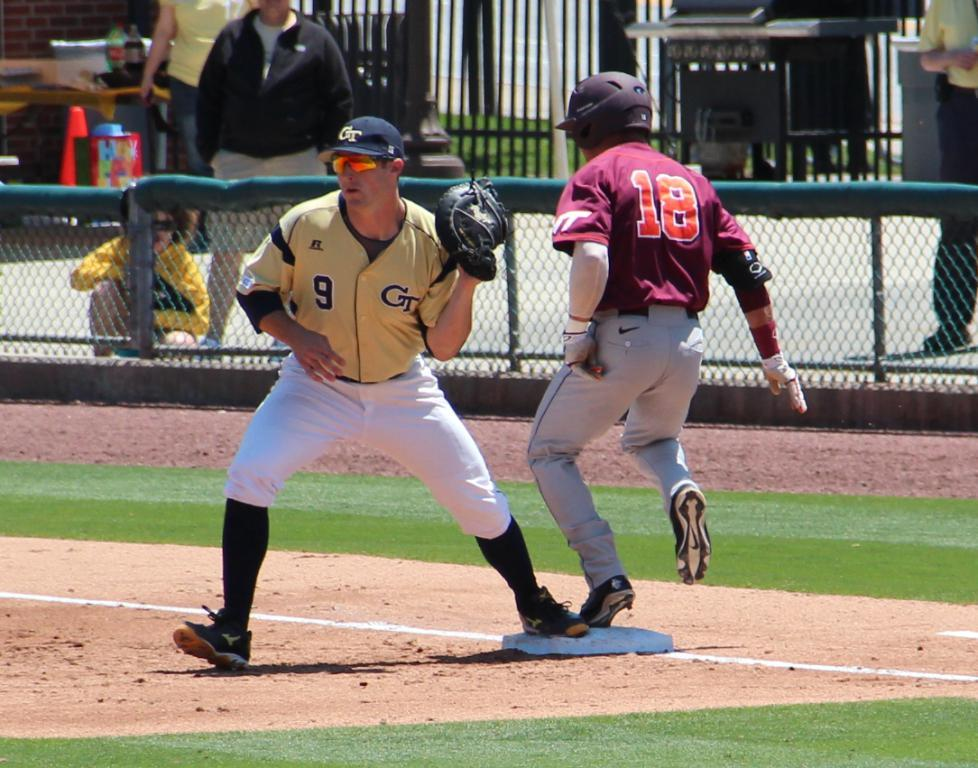<image>
Summarize the visual content of the image. A baseball player with the number 18 on his jersey got on base. 